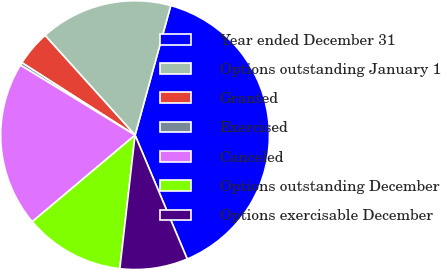<chart> <loc_0><loc_0><loc_500><loc_500><pie_chart><fcel>Year ended December 31<fcel>Options outstanding January 1<fcel>Granted<fcel>Exercised<fcel>Canceled<fcel>Options outstanding December<fcel>Options exercisable December<nl><fcel>39.38%<fcel>15.96%<fcel>4.25%<fcel>0.34%<fcel>19.86%<fcel>12.05%<fcel>8.15%<nl></chart> 